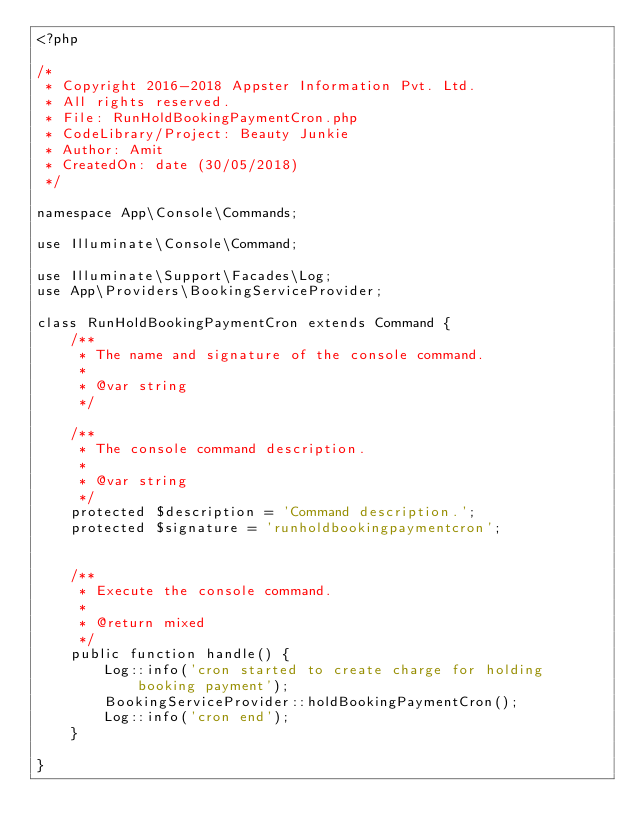<code> <loc_0><loc_0><loc_500><loc_500><_PHP_><?php

/*
 * Copyright 2016-2018 Appster Information Pvt. Ltd. 
 * All rights reserved.
 * File: RunHoldBookingPaymentCron.php
 * CodeLibrary/Project: Beauty Junkie
 * Author: Amit
 * CreatedOn: date (30/05/2018) 
 */

namespace App\Console\Commands;

use Illuminate\Console\Command;

use Illuminate\Support\Facades\Log;
use App\Providers\BookingServiceProvider;

class RunHoldBookingPaymentCron extends Command {
    /**
     * The name and signature of the console command.
     *
     * @var string
     */

    /**
     * The console command description.
     *
     * @var string
     */
    protected $description = 'Command description.';
    protected $signature = 'runholdbookingpaymentcron';


    /**
     * Execute the console command.
     *
     * @return mixed
     */
    public function handle() {
        Log::info('cron started to create charge for holding booking payment');
        BookingServiceProvider::holdBookingPaymentCron();
        Log::info('cron end');
    }

}
</code> 